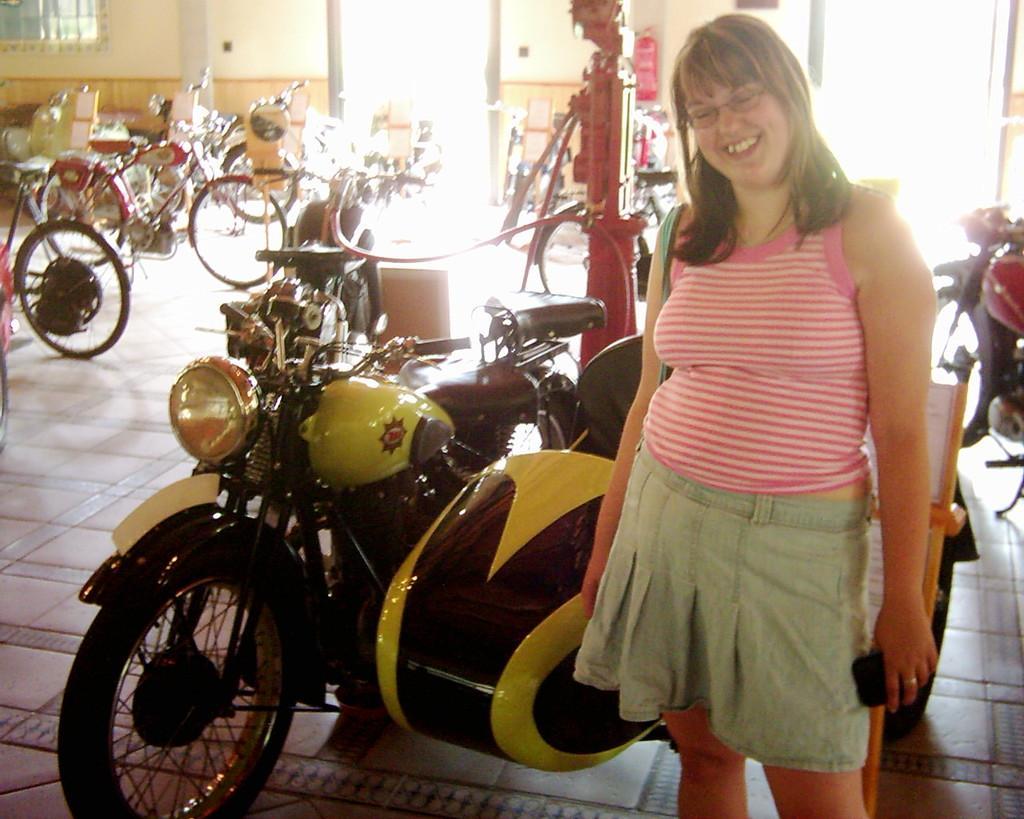In one or two sentences, can you explain what this image depicts? In this image there is a woman standing with a smile on her face and she is holding an object, beside and behind her there are a few vehicles and a few bicycles, some metal structures, few objects, a board with some text and in the background there is a wall and a window. 